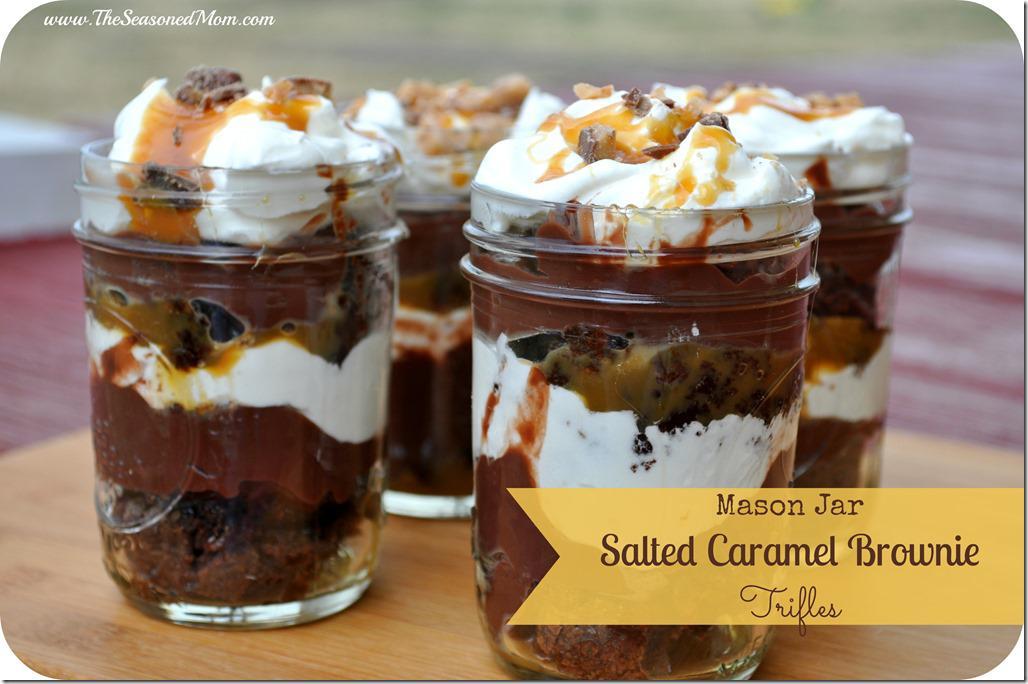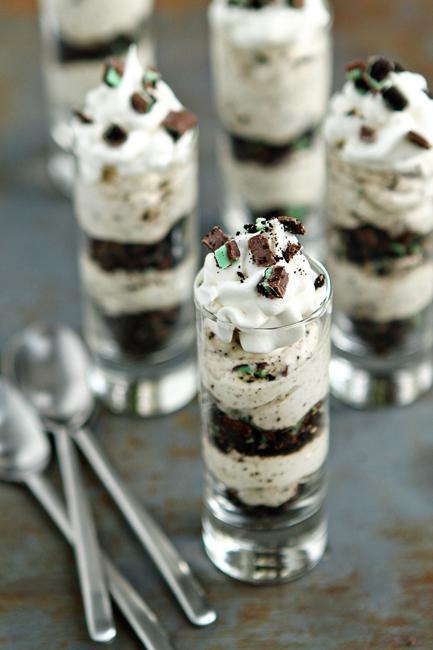The first image is the image on the left, the second image is the image on the right. Assess this claim about the two images: "An image shows a cream-layered dessert in a clear footed glass.". Correct or not? Answer yes or no. No. The first image is the image on the left, the second image is the image on the right. For the images displayed, is the sentence "There are three silver spoons next to the desserts in one of the images." factually correct? Answer yes or no. Yes. 